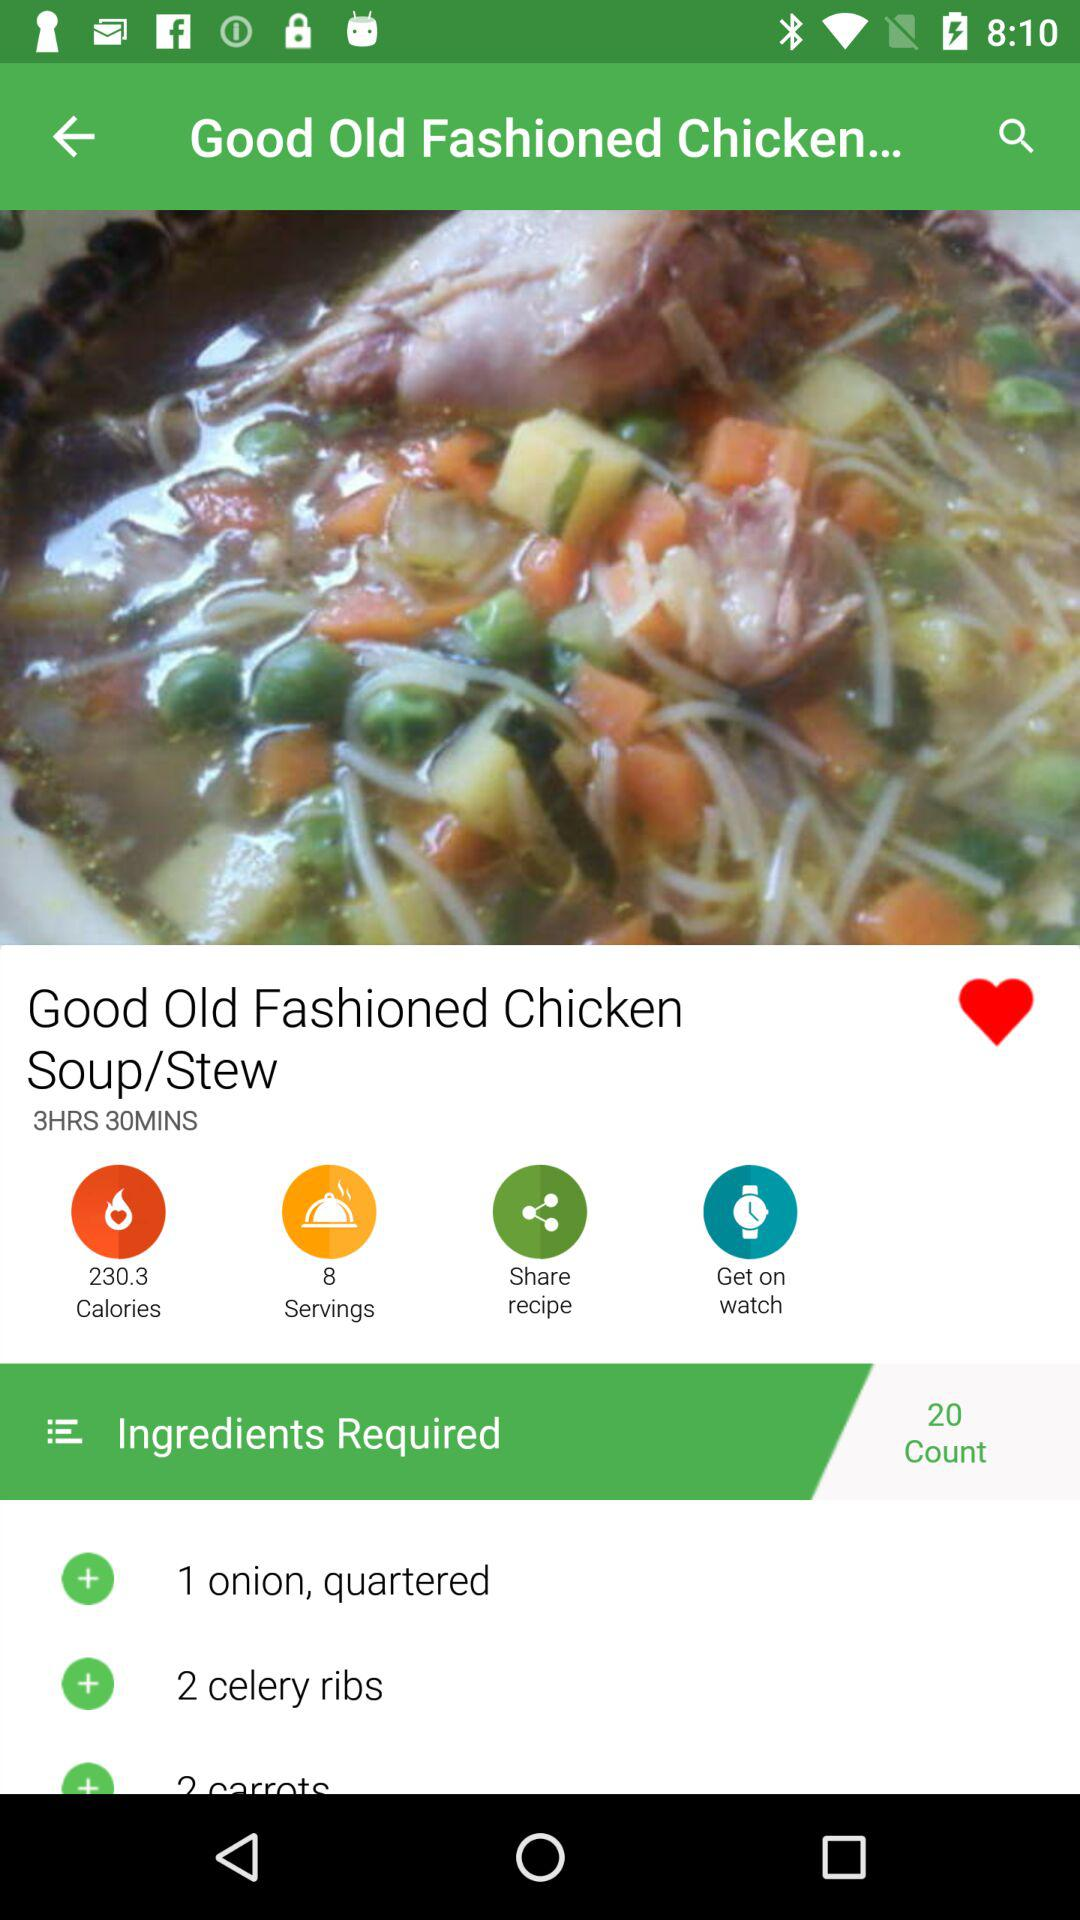What is the total count of ingredients? The total count of ingredients is 20. 